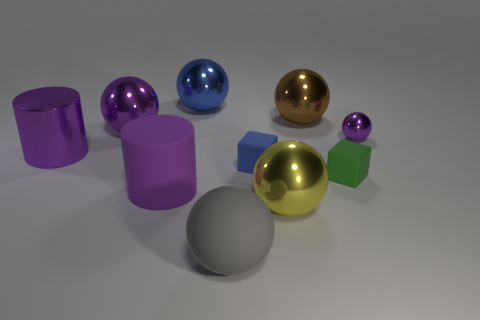What shape is the green rubber thing?
Make the answer very short. Cube. How many rubber balls are the same size as the blue shiny object?
Offer a terse response. 1. Do the large yellow shiny thing and the big blue metal object have the same shape?
Your response must be concise. Yes. There is a thing on the left side of the purple sphere left of the brown metallic sphere; what color is it?
Make the answer very short. Purple. What size is the purple shiny object that is behind the big shiny cylinder and to the left of the big purple rubber thing?
Keep it short and to the point. Large. Is there anything else that has the same color as the big metal cylinder?
Offer a very short reply. Yes. The small object that is the same material as the green cube is what shape?
Provide a short and direct response. Cube. Do the large blue thing and the purple object that is behind the tiny metallic thing have the same shape?
Provide a succinct answer. Yes. What is the material of the large thing that is right of the large metal object in front of the green matte cube?
Offer a very short reply. Metal. Is the number of large blue metal things behind the blue cube the same as the number of big purple rubber cylinders?
Ensure brevity in your answer.  Yes. 